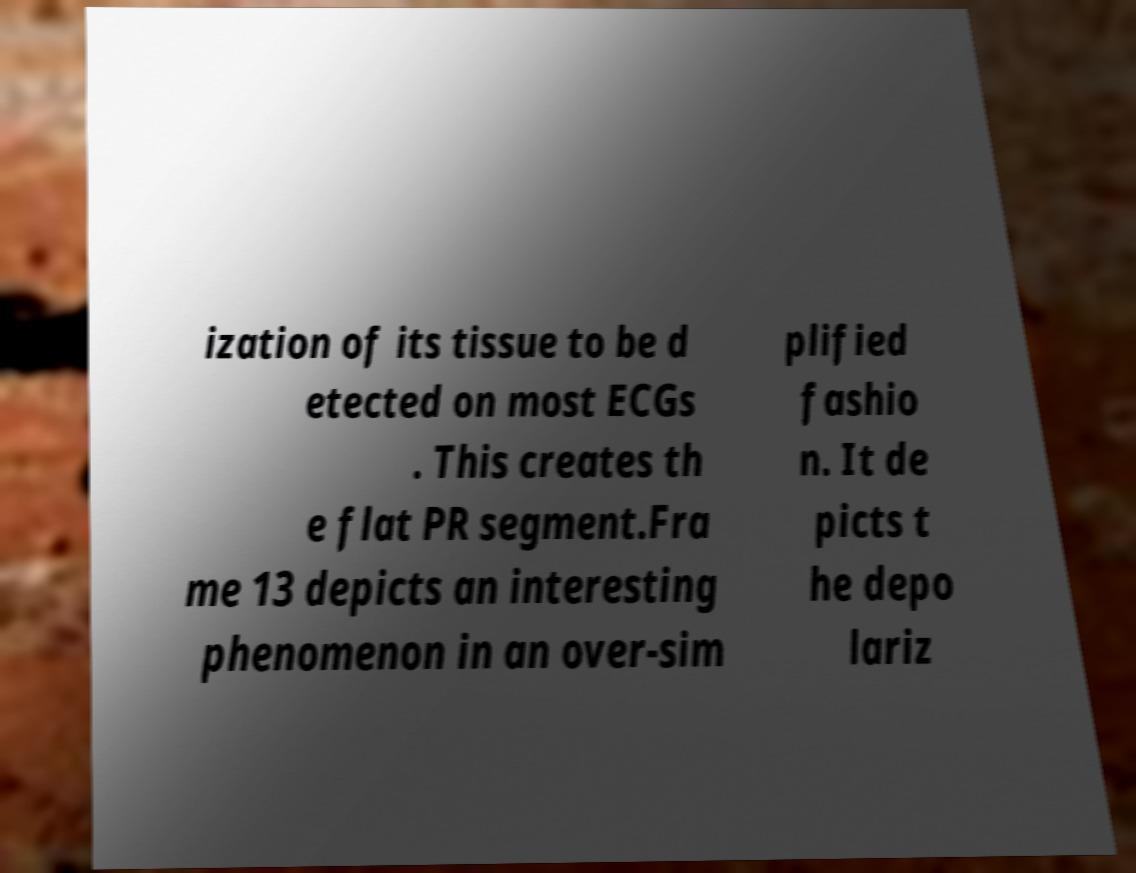There's text embedded in this image that I need extracted. Can you transcribe it verbatim? ization of its tissue to be d etected on most ECGs . This creates th e flat PR segment.Fra me 13 depicts an interesting phenomenon in an over-sim plified fashio n. It de picts t he depo lariz 